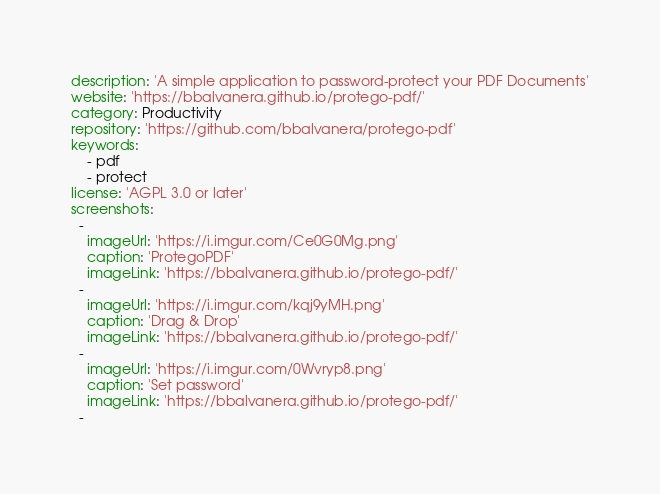<code> <loc_0><loc_0><loc_500><loc_500><_YAML_>description: 'A simple application to password-protect your PDF Documents'
website: 'https://bbalvanera.github.io/protego-pdf/'
category: Productivity
repository: 'https://github.com/bbalvanera/protego-pdf'
keywords:
    - pdf
    - protect
license: 'AGPL 3.0 or later'
screenshots:
  -
    imageUrl: 'https://i.imgur.com/Ce0G0Mg.png'
    caption: 'ProtegoPDF'
    imageLink: 'https://bbalvanera.github.io/protego-pdf/'
  -
    imageUrl: 'https://i.imgur.com/kqj9yMH.png'
    caption: 'Drag & Drop'
    imageLink: 'https://bbalvanera.github.io/protego-pdf/'
  -
    imageUrl: 'https://i.imgur.com/0Wvryp8.png'
    caption: 'Set password'
    imageLink: 'https://bbalvanera.github.io/protego-pdf/'
  -</code> 